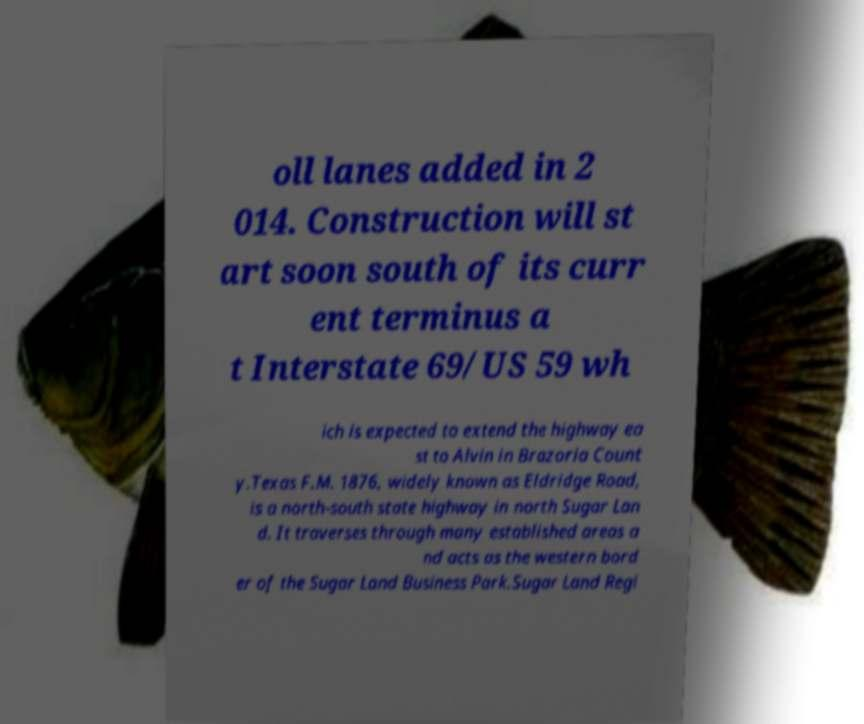Can you accurately transcribe the text from the provided image for me? oll lanes added in 2 014. Construction will st art soon south of its curr ent terminus a t Interstate 69/US 59 wh ich is expected to extend the highway ea st to Alvin in Brazoria Count y.Texas F.M. 1876, widely known as Eldridge Road, is a north-south state highway in north Sugar Lan d. It traverses through many established areas a nd acts as the western bord er of the Sugar Land Business Park.Sugar Land Regi 